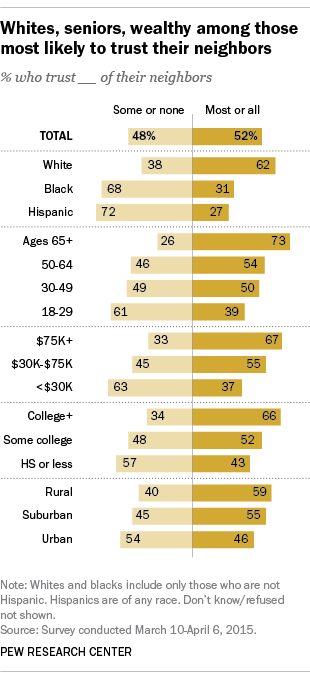Identify some key points in this picture. Out of the total number of bars, how many have a value equal to 55? According to a survey, 62% of white people trust most or all of their neighbors. 